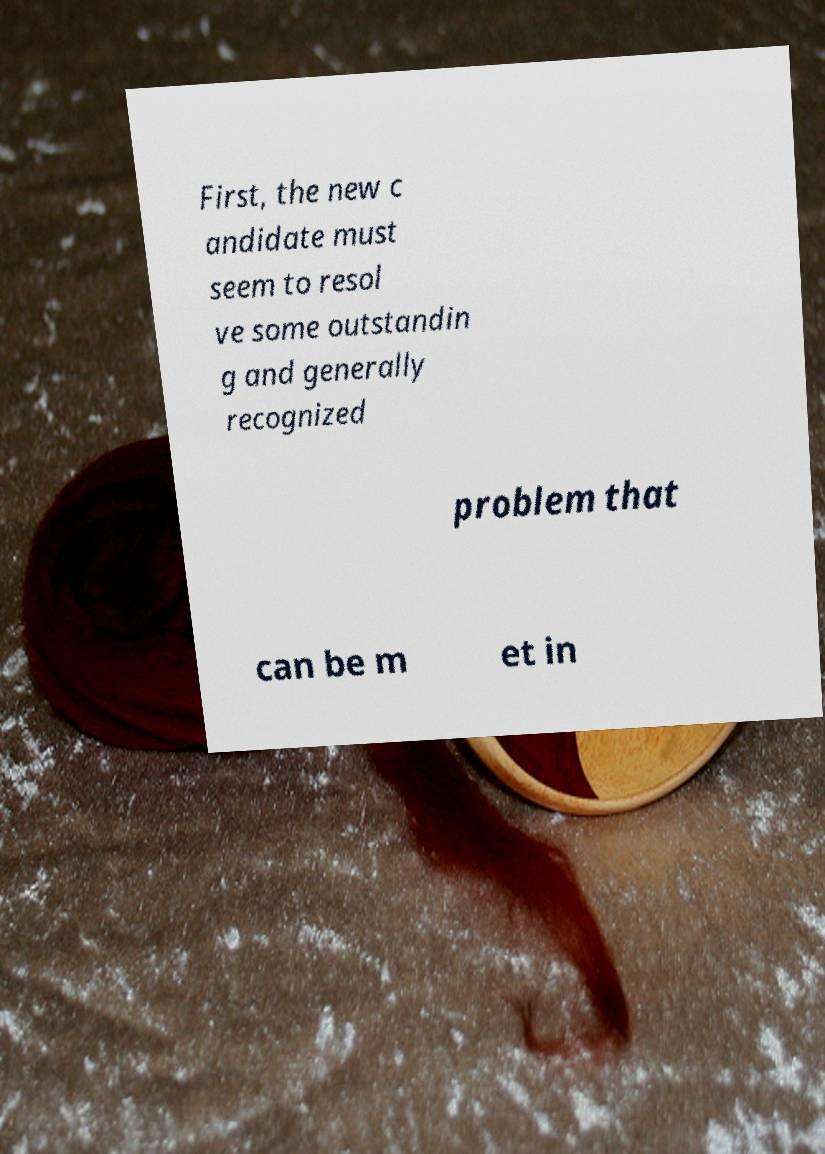Can you read and provide the text displayed in the image?This photo seems to have some interesting text. Can you extract and type it out for me? First, the new c andidate must seem to resol ve some outstandin g and generally recognized problem that can be m et in 